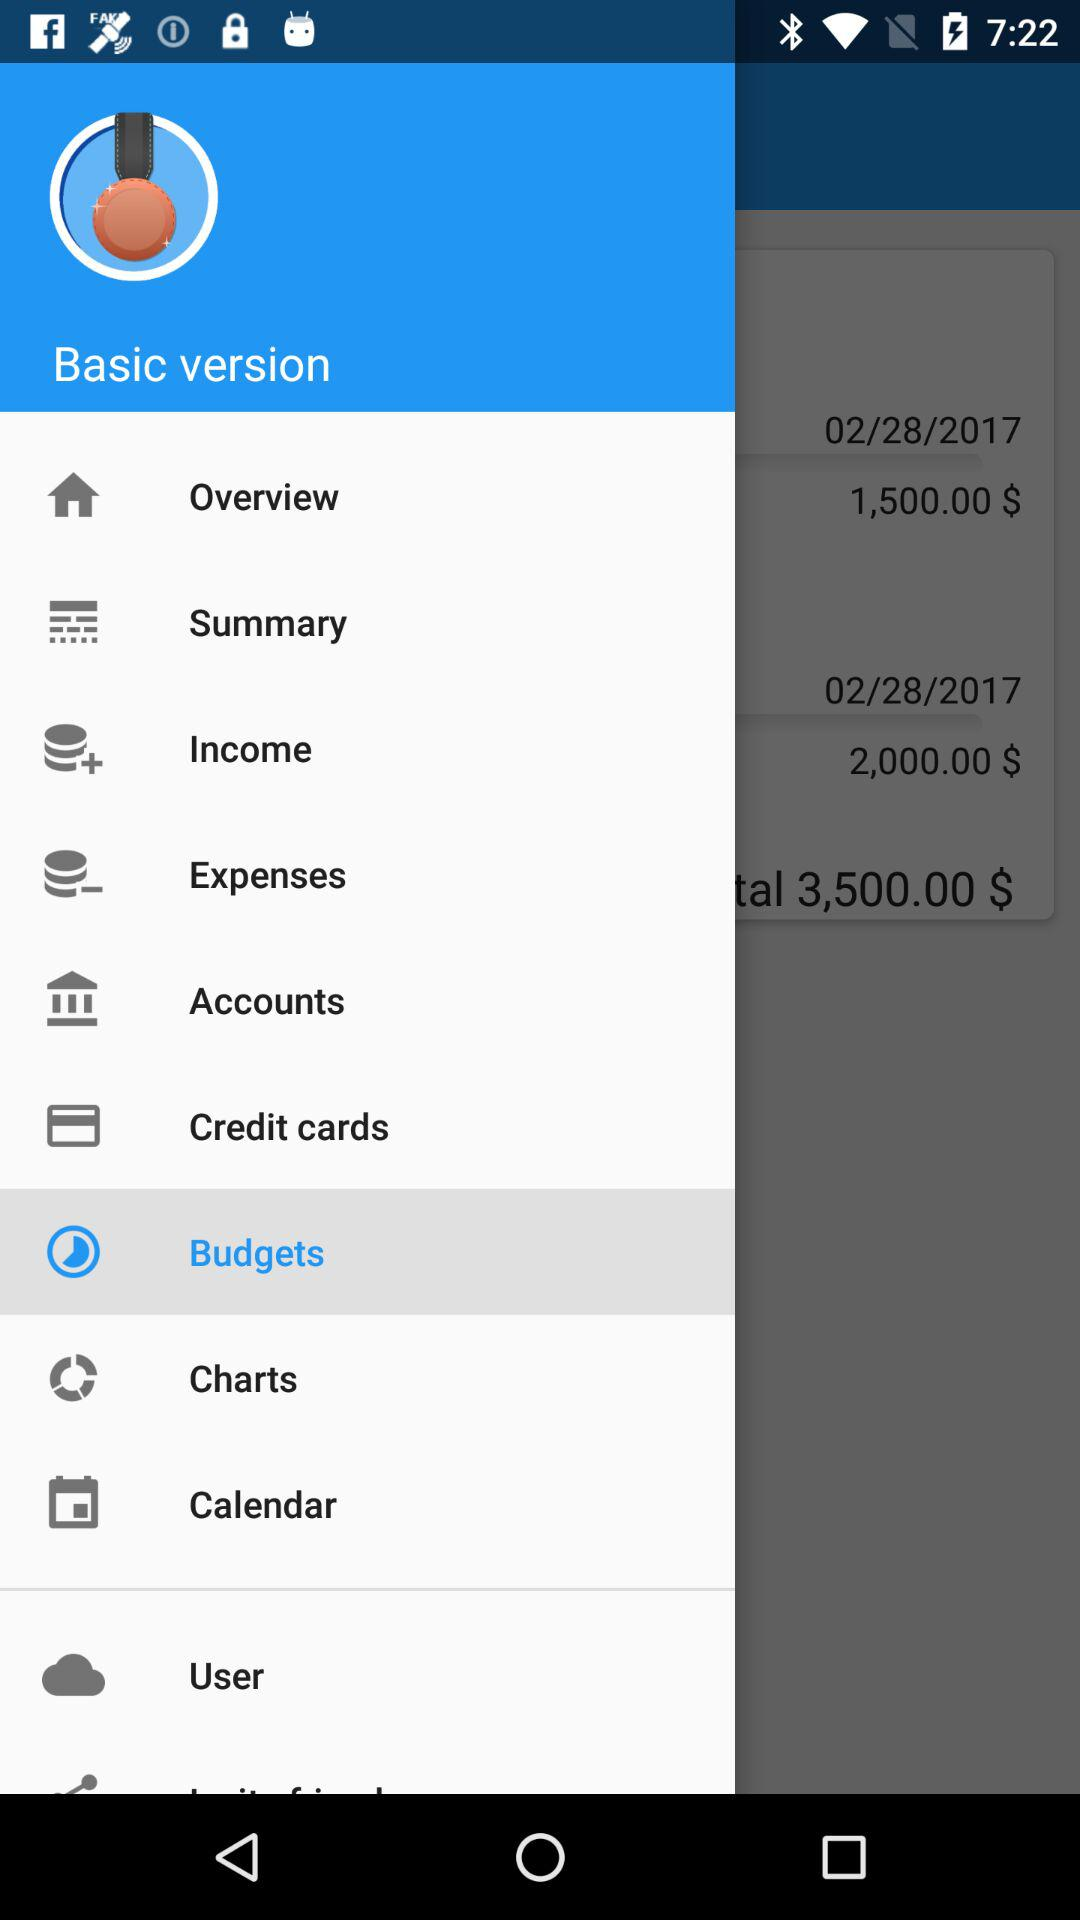How much money is in my accounts?
Answer the question using a single word or phrase. 3,500.00 $ 